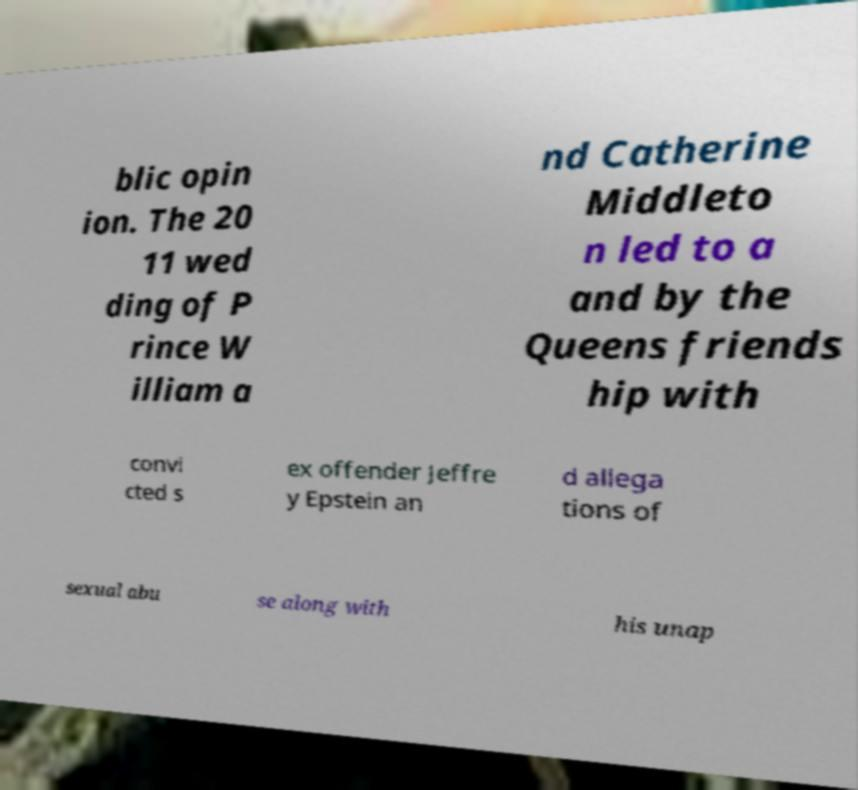Can you accurately transcribe the text from the provided image for me? blic opin ion. The 20 11 wed ding of P rince W illiam a nd Catherine Middleto n led to a and by the Queens friends hip with convi cted s ex offender Jeffre y Epstein an d allega tions of sexual abu se along with his unap 